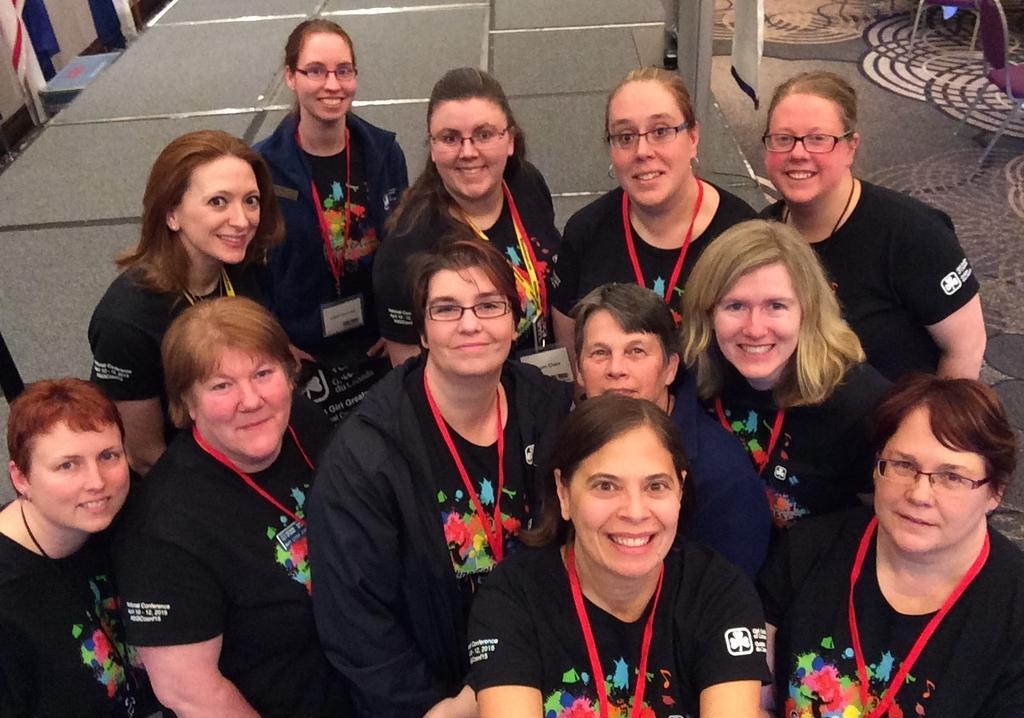How would you summarize this image in a sentence or two? In this picture there are people smiling and we can see chairs, floor, cloth and few objects. 